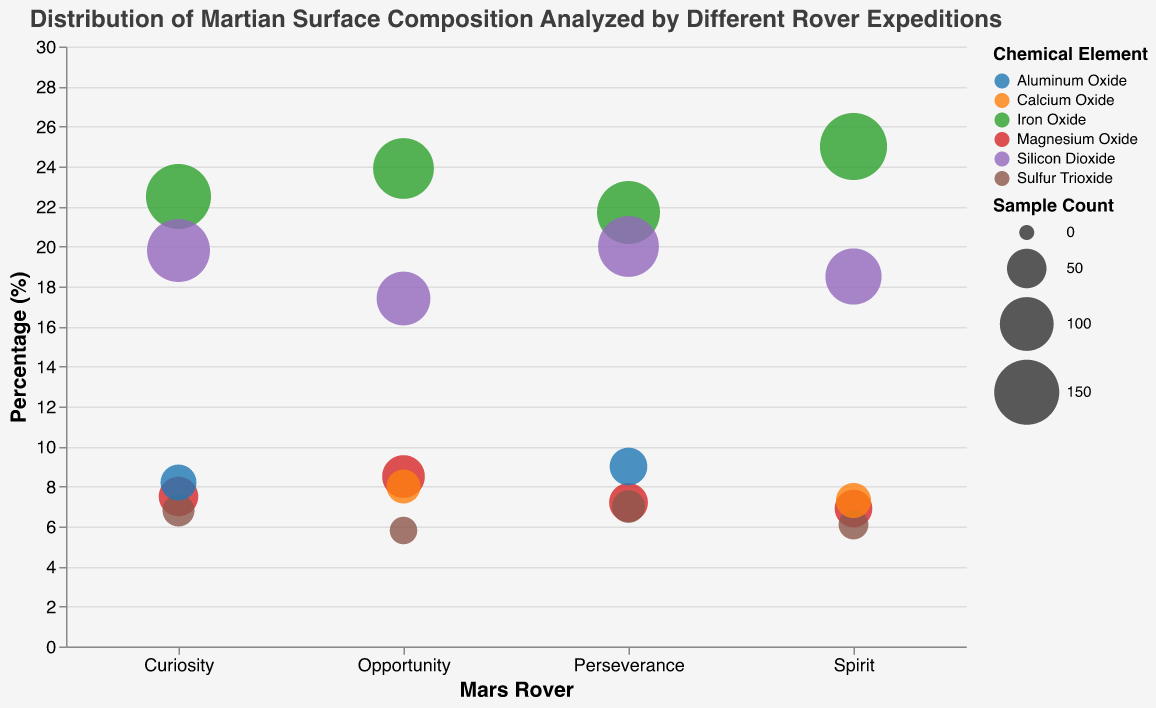What rover analyzed the highest percentage of Iron Oxide? Look at the "percentage" axis for Iron Oxide. The Spirit rover analyzed the highest percentage at 25.0%.
Answer: Spirit Which chemical element did Perseverance find with the highest percentage? Refer to the elements analyzed by Perseverance and compare their percentages. Silicon Dioxide has the highest percentage at 20.0%.
Answer: Silicon Dioxide How many different locations are analyzed by the rovers? Each rover's data includes a specific location. There are Gale Crater, Endurance Crater, Gusev Crater, and Jezero Crater, making a total of 4 locations.
Answer: 4 What is the average percentage of Silicon Dioxide analyzed across all rovers? Add the percentages of Silicon Dioxide for all rovers and divide by the number of rovers. (19.8 + 17.4 + 18.5 + 20.0) / 4 = 18.925.
Answer: 18.93 Which rover analyzed the highest count of samples? Looking at the size of the bubbles, which represents sample count, the Spirit rover analyzed 160 samples for Iron Oxide, which is the highest count.
Answer: Spirit Compare the percentage of Magnesium Oxide analyzed by Opportunity and Perseverance. Which rover found a higher percentage? Check the percentages of Magnesium Oxide for both rovers. Opportunity found 8.5%, while Perseverance found 7.2%. Opportunity has a higher percentage.
Answer: Opportunity What is the sum of the percentages for Sulfur Trioxide analyzed by all rovers? Add the percentages of Sulfur Trioxide for all rovers. 6.8 + 5.8 + 6.1 + 7.0 = 25.7.
Answer: 25.7 Which chemical element has the most consistent percentage across all rovers? Compare the range of percentages for each element across all rovers. Iron Oxide percentages range from 21.7% to 25.0%, showing little variance, making it the most consistent.
Answer: Iron Oxide How does the percentage of Aluminum Oxide found by Curiosity compare to that found by Perseverance? Curiosity analyzed 8.2% Aluminum Oxide, while Perseverance analyzed 9.0%. Compare: Curiosity’s percentage is lower than Perseverance’s.
Answer: Perseverance found a higher percentage In which location was Calcium Oxide found, and what were its percentages? Check the data for Calcium Oxide. It's found in Endurance Crater (8.0%) by Opportunity and Gusev Crater (7.3%) by Spirit.
Answer: Endurance Crater (8.0%), Gusev Crater (7.3%) 